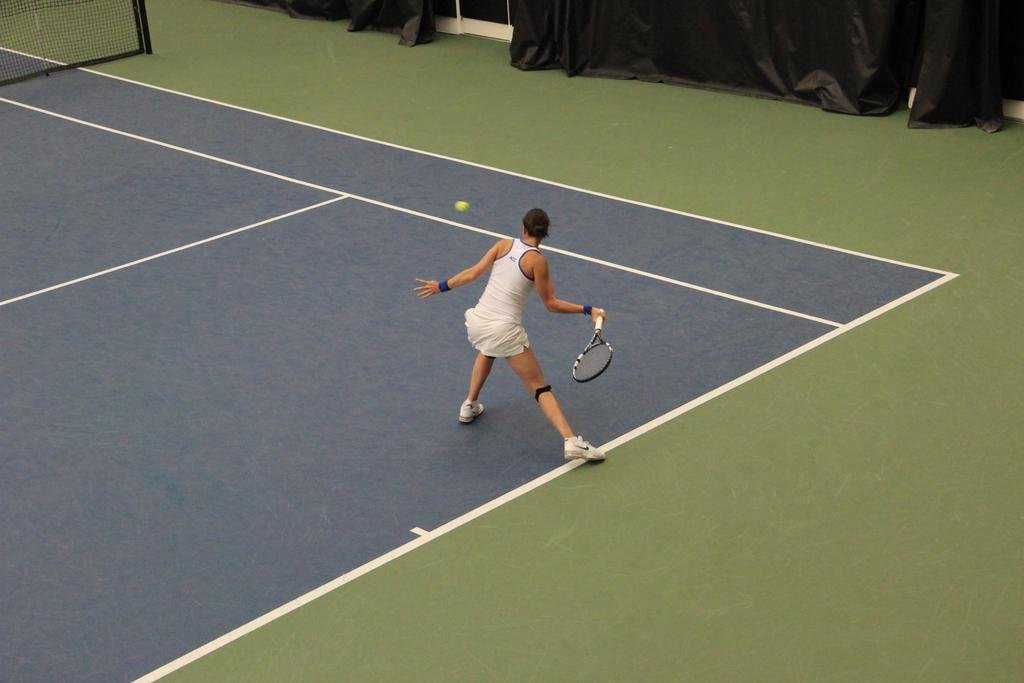Where is the girl in the image located? The girl is standing on a tennis court. What activity is the girl engaged in? The girl is playing tennis. What equipment is the girl using to play tennis? The girl is holding a tennis racket. What can be seen on the right side of the image? There are curtains on the right side of the image. What separates the two sides of the tennis court? There is a net in the center of the image. What color is the girl's skirt in the image? There is no mention of a skirt in the provided facts, so we cannot determine the color of the girl's skirt from the image. 